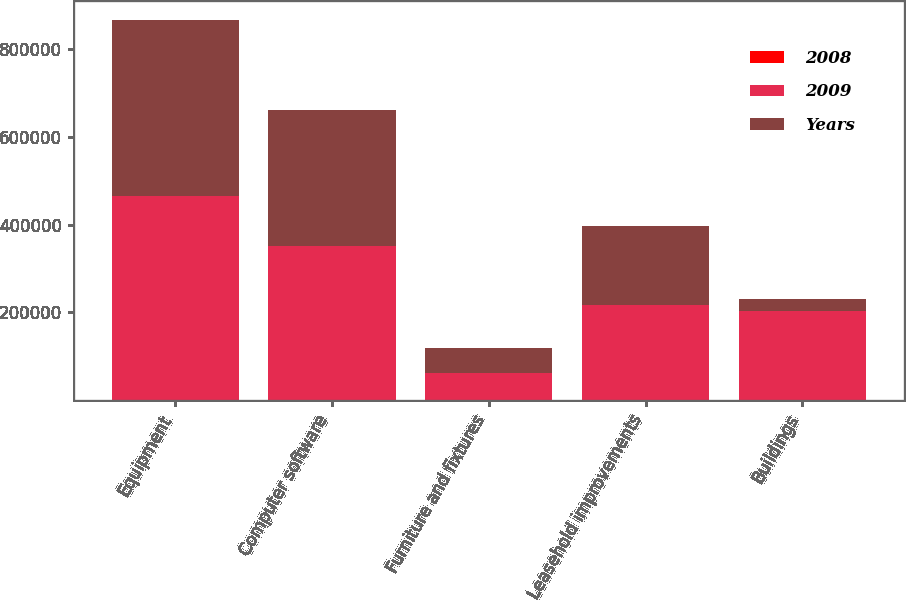Convert chart to OTSL. <chart><loc_0><loc_0><loc_500><loc_500><stacked_bar_chart><ecel><fcel>Equipment<fcel>Computer software<fcel>Furniture and fixtures<fcel>Leasehold improvements<fcel>Buildings<nl><fcel>2008<fcel>35<fcel>35<fcel>5<fcel>211<fcel>530<nl><fcel>2009<fcel>466543<fcel>350950<fcel>61951<fcel>217321<fcel>201513<nl><fcel>Years<fcel>400111<fcel>310789<fcel>55590<fcel>180621<fcel>27760<nl></chart> 